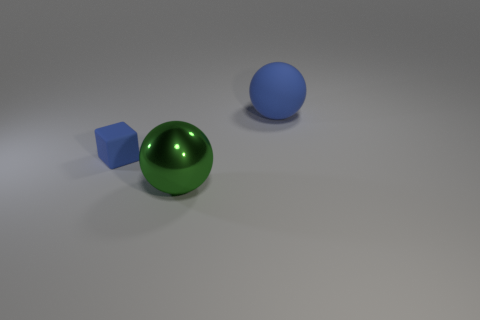Does the object that is behind the tiny blue matte block have the same shape as the large object that is in front of the cube?
Your response must be concise. Yes. There is a blue rubber ball; does it have the same size as the blue matte thing that is to the left of the large blue ball?
Offer a very short reply. No. How many other things are there of the same material as the big green sphere?
Your answer should be very brief. 0. Are there any other things that are the same shape as the tiny thing?
Make the answer very short. No. There is a big shiny thing to the left of the blue thing on the right side of the object that is to the left of the green metal ball; what is its color?
Make the answer very short. Green. What shape is the thing that is behind the large green thing and right of the matte cube?
Your answer should be very brief. Sphere. Is there anything else that is the same size as the block?
Provide a succinct answer. No. The large thing in front of the rubber thing to the left of the big matte object is what color?
Offer a terse response. Green. There is a blue thing on the left side of the blue matte thing behind the blue object to the left of the shiny object; what shape is it?
Provide a succinct answer. Cube. How big is the object that is both behind the green shiny sphere and to the right of the tiny matte block?
Ensure brevity in your answer.  Large. 